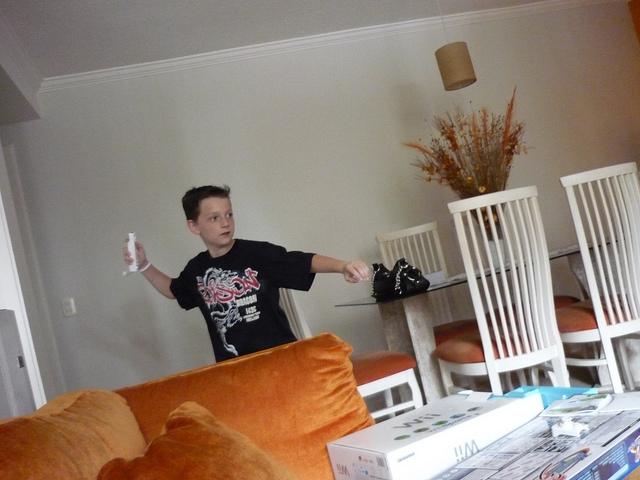Do you like the boy's t-shirt?
Write a very short answer. No. What color is the couch?
Write a very short answer. Orange. Where is the man?
Quick response, please. Living room. Is that boy playing with an Xbox?
Concise answer only. No. 